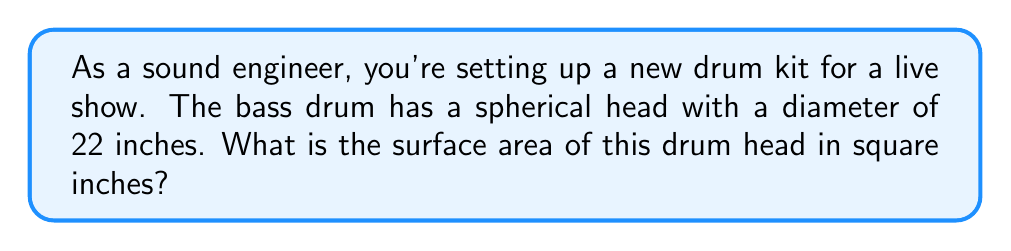Teach me how to tackle this problem. Let's approach this step-by-step:

1) The drum head is a circular surface, which is part of a sphere. The surface area of a circle is given by the formula:

   $$A = \pi r^2$$

   where $r$ is the radius of the circle.

2) We're given the diameter of the drum head, which is 22 inches. To find the radius, we divide the diameter by 2:

   $$r = \frac{22}{2} = 11\text{ inches}$$

3) Now we can substitute this into our formula:

   $$A = \pi (11)^2$$

4) Simplify:
   $$A = 121\pi\text{ square inches}$$

5) If we want to calculate the exact value, we can use $\pi \approx 3.14159$:

   $$A \approx 121 * 3.14159 \approx 380.13\text{ square inches}$$

Note: In practice, we often leave the answer in terms of $\pi$ for precision, unless a decimal approximation is specifically requested.
Answer: $121\pi\text{ square inches}$ or approximately $380.13\text{ square inches}$ 